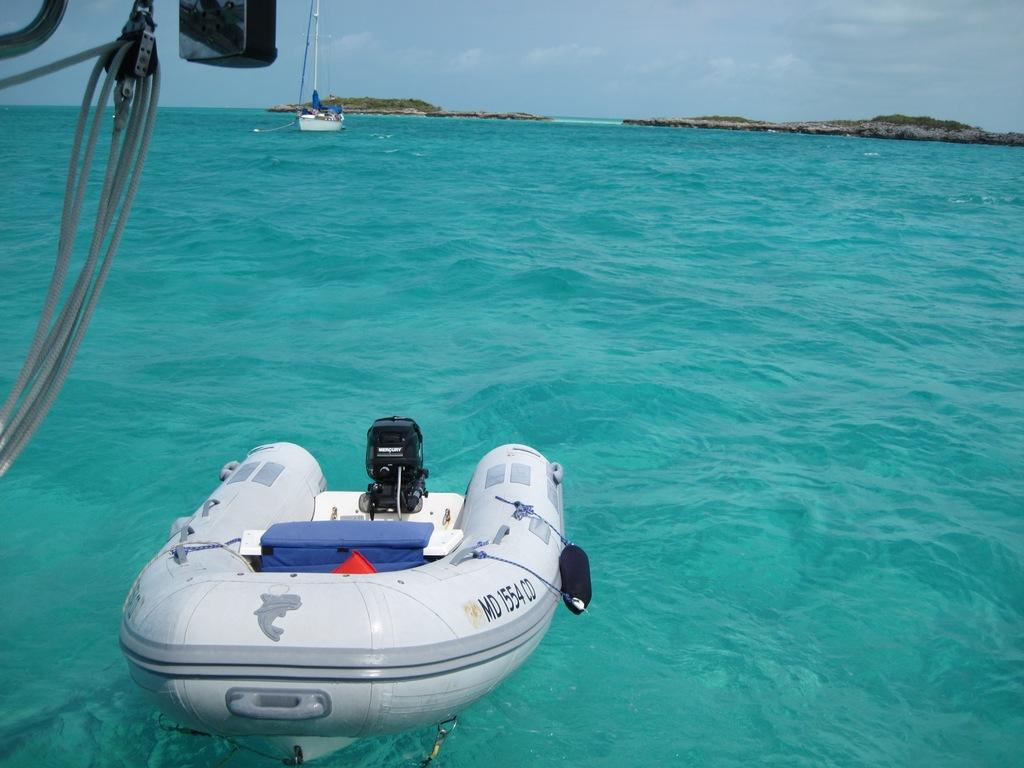What type of vehicles can be seen in the image? There are boats in the image. What objects are connected to the boats in the image? There are ropes in the image that are connected to the boats. What natural element is visible in the image? There is water visible in the image. What type of landscape can be seen at the top of the image? There are hills and trees at the top of the image. What is visible in the sky at the top of the image? Clouds are visible in the sky at the top of the image. What type of war is being fought in the image? There is no war present in the image; it features boats, ropes, water, hills, trees, and clouds. What smell can be detected in the image? There is no mention of any smell in the image, as it focuses on visual elements. 